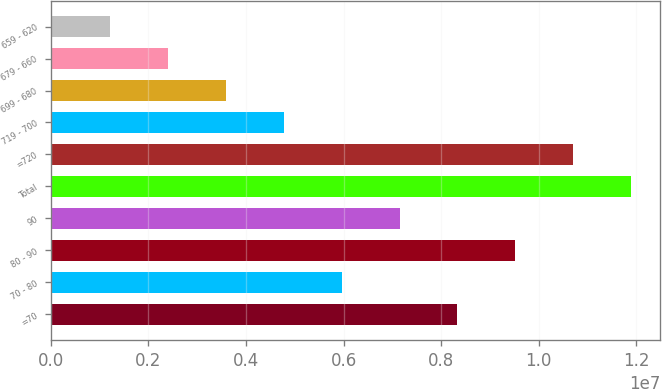<chart> <loc_0><loc_0><loc_500><loc_500><bar_chart><fcel>=70<fcel>70 - 80<fcel>80 - 90<fcel>90<fcel>Total<fcel>=720<fcel>719 - 700<fcel>699 - 680<fcel>679 - 660<fcel>659 - 620<nl><fcel>8.33637e+06<fcel>5.95973e+06<fcel>9.52469e+06<fcel>7.14805e+06<fcel>1.19013e+07<fcel>1.0713e+07<fcel>4.77141e+06<fcel>3.58309e+06<fcel>2.39477e+06<fcel>1.20645e+06<nl></chart> 